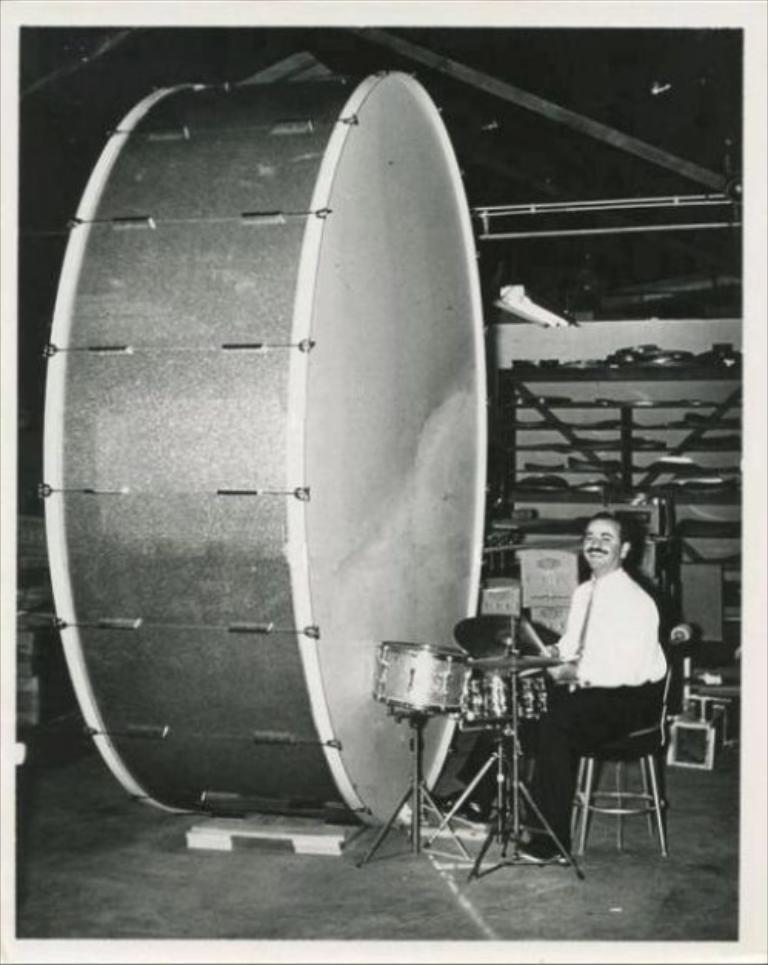What is the person in the image doing? The person is sitting on a chair in the image. What is the person holding? The person is holding something in the image. What other items can be seen in the image besides the person? There are musical instruments and other objects in the image. How is the image presented? The image is in black and white. Can you tell me how many frogs are sitting on the person's lap in the image? There are no frogs present in the image; it only features a person sitting on a chair, holding something, and surrounded by musical instruments and other objects. 